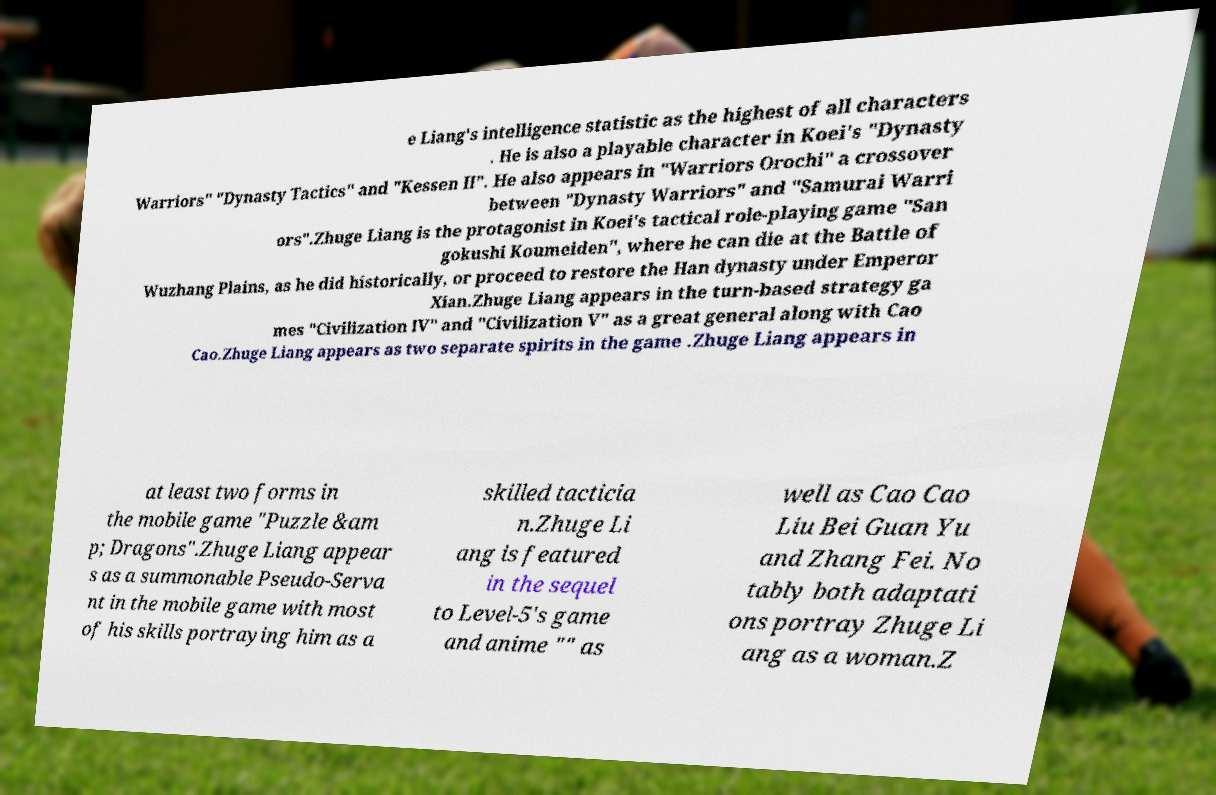Can you accurately transcribe the text from the provided image for me? e Liang's intelligence statistic as the highest of all characters . He is also a playable character in Koei's "Dynasty Warriors" "Dynasty Tactics" and "Kessen II". He also appears in "Warriors Orochi" a crossover between "Dynasty Warriors" and "Samurai Warri ors".Zhuge Liang is the protagonist in Koei's tactical role-playing game "San gokushi Koumeiden", where he can die at the Battle of Wuzhang Plains, as he did historically, or proceed to restore the Han dynasty under Emperor Xian.Zhuge Liang appears in the turn-based strategy ga mes "Civilization IV" and "Civilization V" as a great general along with Cao Cao.Zhuge Liang appears as two separate spirits in the game .Zhuge Liang appears in at least two forms in the mobile game "Puzzle &am p; Dragons".Zhuge Liang appear s as a summonable Pseudo-Serva nt in the mobile game with most of his skills portraying him as a skilled tacticia n.Zhuge Li ang is featured in the sequel to Level-5's game and anime "" as well as Cao Cao Liu Bei Guan Yu and Zhang Fei. No tably both adaptati ons portray Zhuge Li ang as a woman.Z 